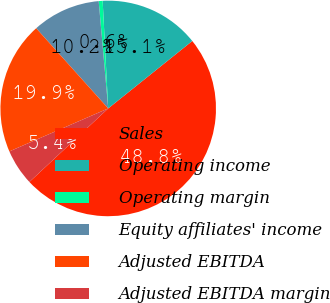Convert chart to OTSL. <chart><loc_0><loc_0><loc_500><loc_500><pie_chart><fcel>Sales<fcel>Operating income<fcel>Operating margin<fcel>Equity affiliates' income<fcel>Adjusted EBITDA<fcel>Adjusted EBITDA margin<nl><fcel>48.81%<fcel>15.06%<fcel>0.59%<fcel>10.24%<fcel>19.88%<fcel>5.42%<nl></chart> 